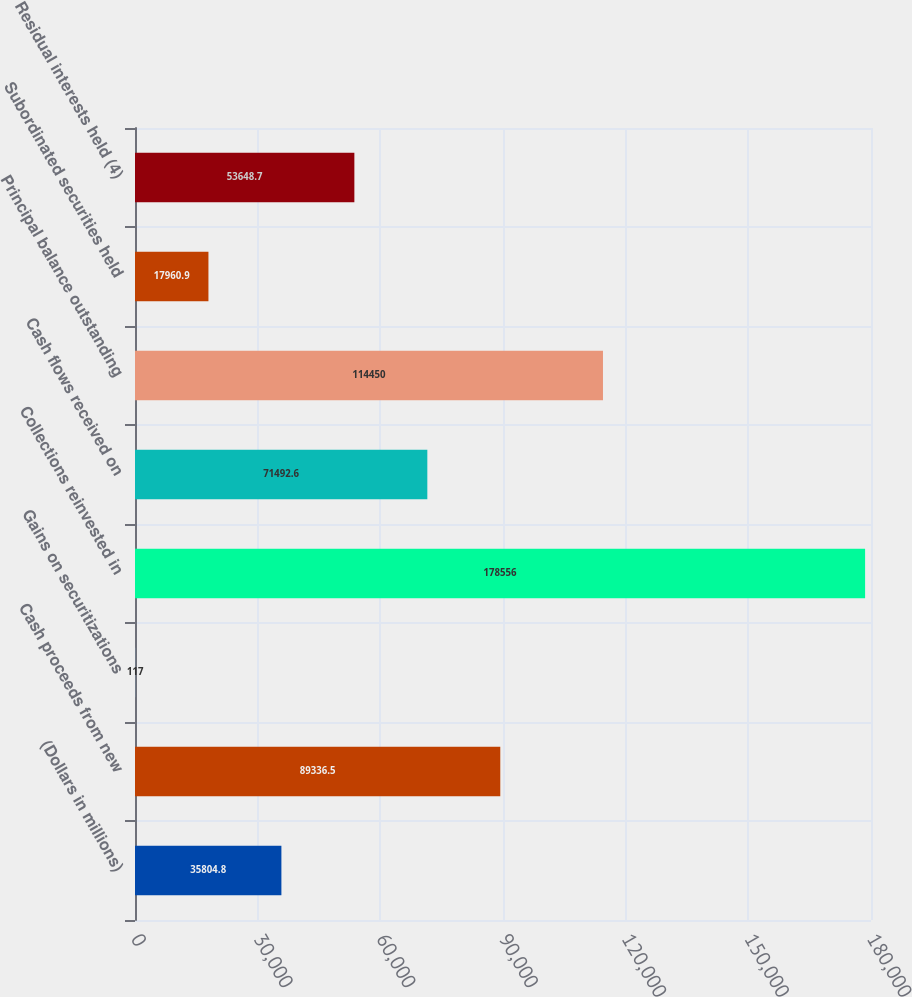Convert chart to OTSL. <chart><loc_0><loc_0><loc_500><loc_500><bar_chart><fcel>(Dollars in millions)<fcel>Cash proceeds from new<fcel>Gains on securitizations<fcel>Collections reinvested in<fcel>Cash flows received on<fcel>Principal balance outstanding<fcel>Subordinated securities held<fcel>Residual interests held (4)<nl><fcel>35804.8<fcel>89336.5<fcel>117<fcel>178556<fcel>71492.6<fcel>114450<fcel>17960.9<fcel>53648.7<nl></chart> 